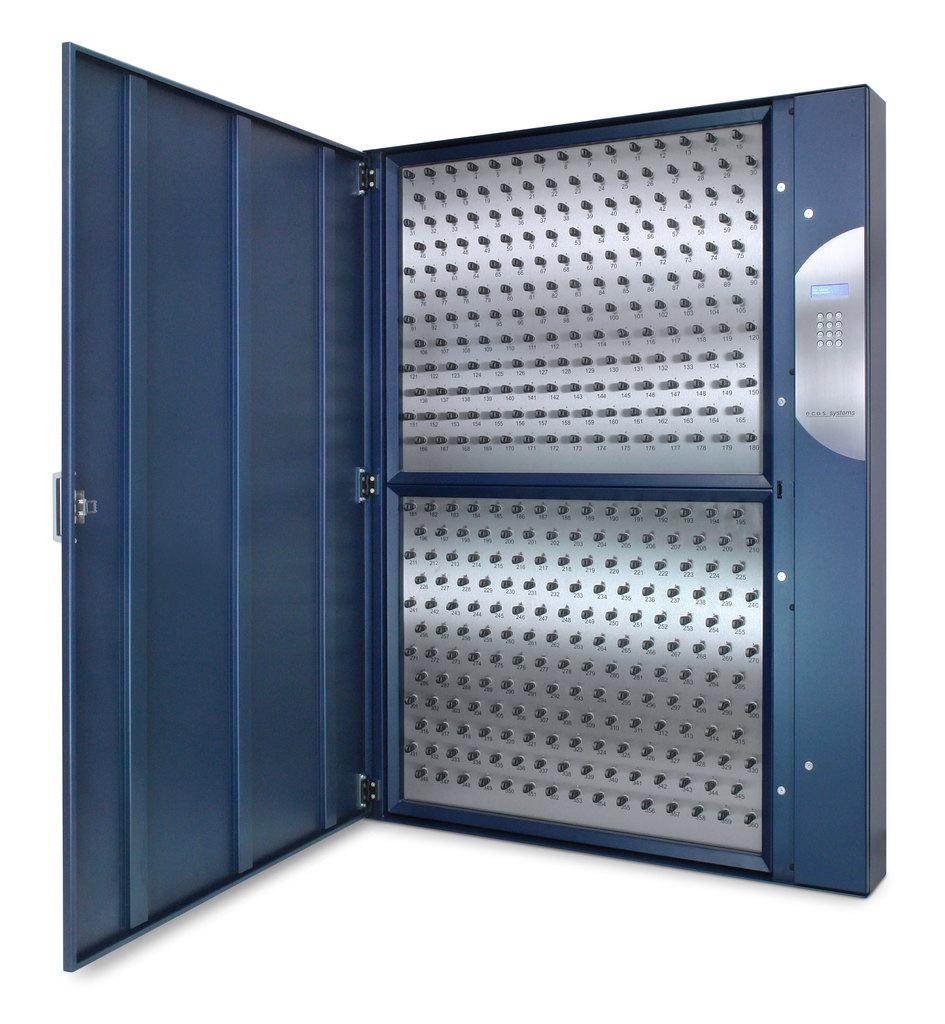What is the main object in the middle of the image? There is a cupboard in the middle of the image. How many fingers can be seen on the cupboard in the image? There are no fingers visible on the cupboard in the image. 